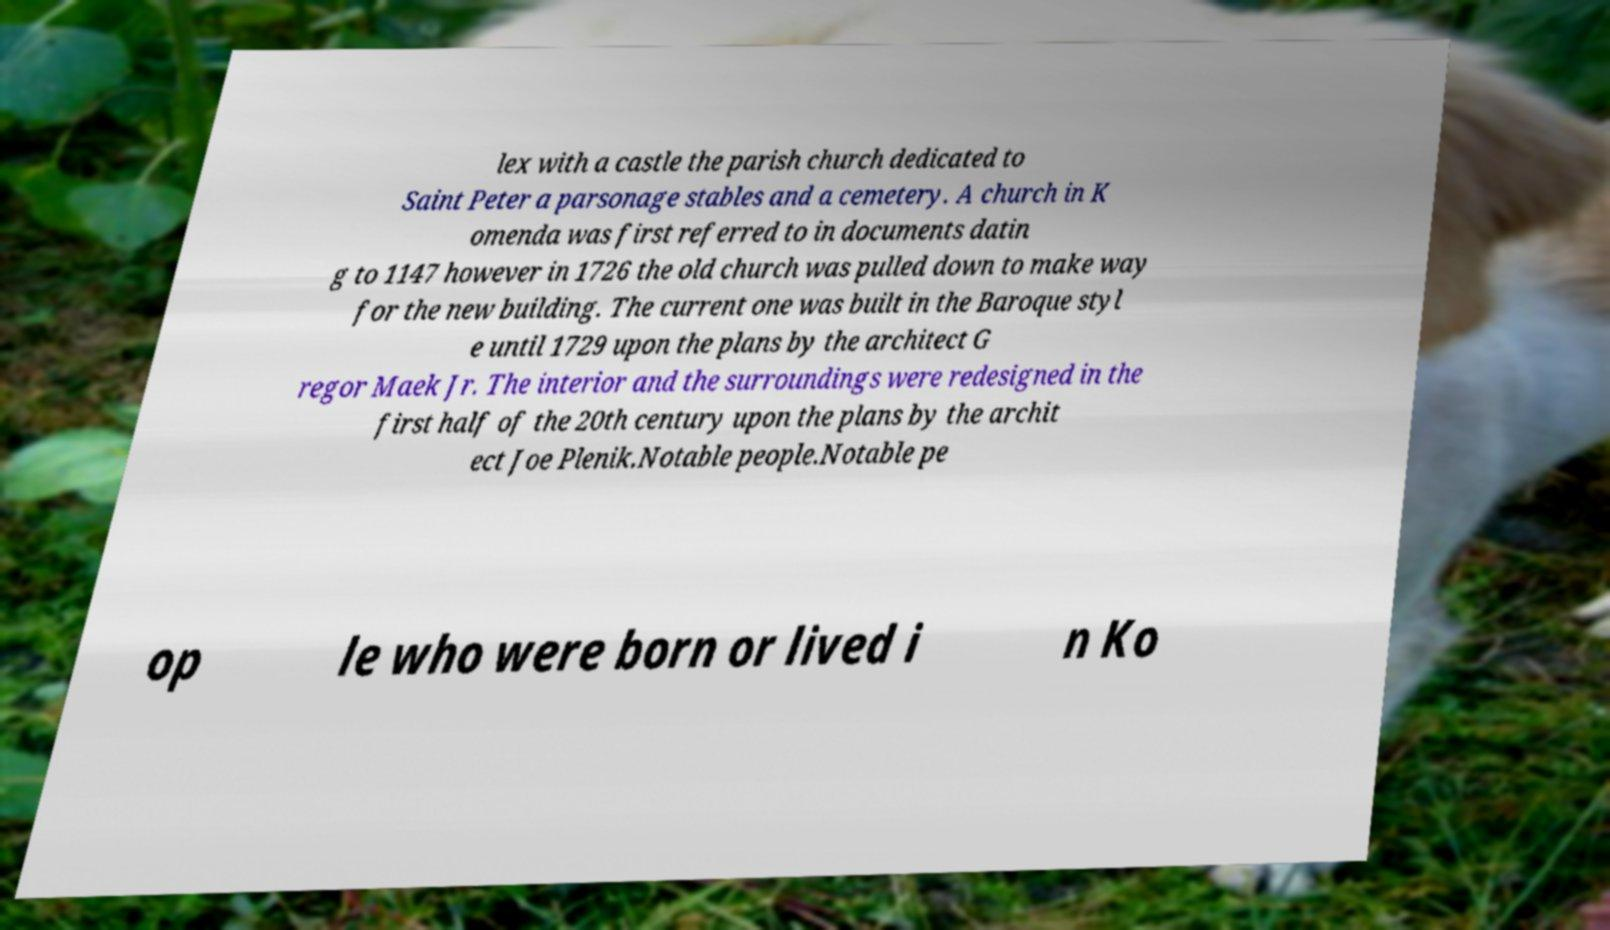What messages or text are displayed in this image? I need them in a readable, typed format. lex with a castle the parish church dedicated to Saint Peter a parsonage stables and a cemetery. A church in K omenda was first referred to in documents datin g to 1147 however in 1726 the old church was pulled down to make way for the new building. The current one was built in the Baroque styl e until 1729 upon the plans by the architect G regor Maek Jr. The interior and the surroundings were redesigned in the first half of the 20th century upon the plans by the archit ect Joe Plenik.Notable people.Notable pe op le who were born or lived i n Ko 